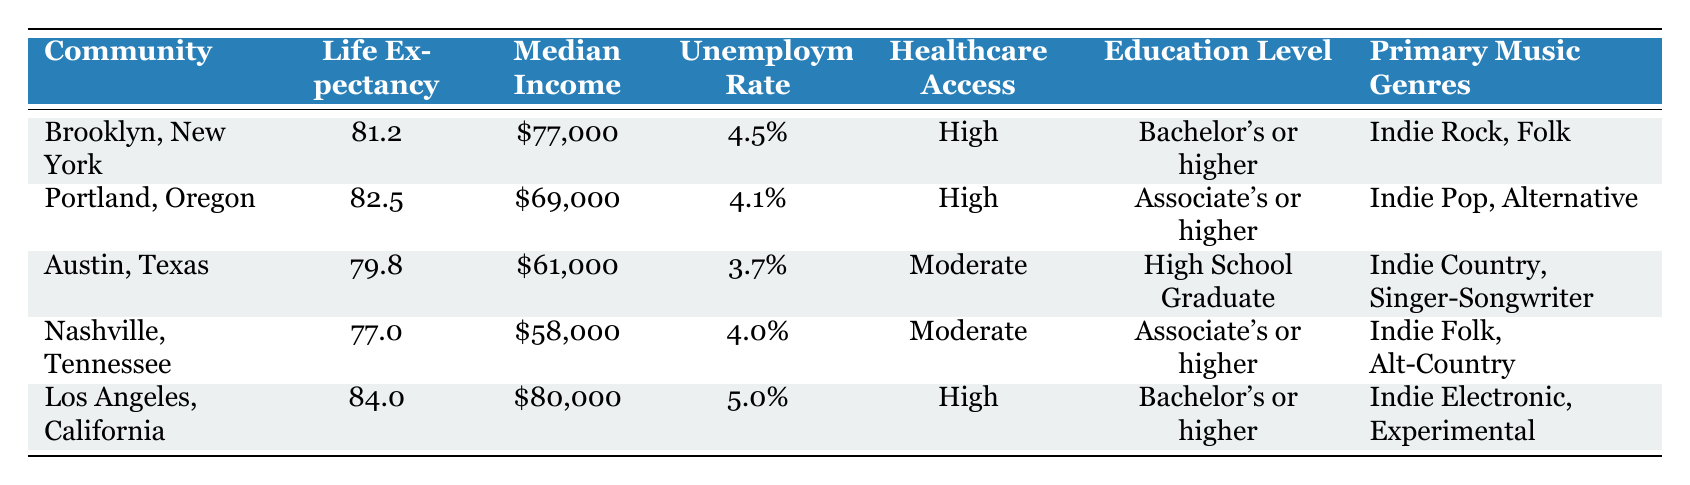What is the average life expectancy across all communities in the table? To find the average life expectancy, add up the average life expectancy values for each community: 81.2 + 82.5 + 79.8 + 77.0 + 84.0 = 404.5. Then, divide by the number of communities (5): 404.5 / 5 = 80.9.
Answer: 80.9 In which community is the median income the highest? By comparing the median income values: Brooklyn has $77,000, Portland $69,000, Austin $61,000, Nashville $58,000, and Los Angeles $80,000. Los Angeles has the highest median income of $80,000.
Answer: Los Angeles, California Which community has a high unemployment rate and moderate access to healthcare? The unemployment rate is high for Los Angeles at 5.0% (but has high healthcare access) and moderate for Austin (3.7%) and Nashville (4.0%). However, Nashville has a moderate unemployment rate (4.0%) and moderate access to healthcare.
Answer: Nashville, Tennessee Is there a community where the median income exceeds the average life expectancy? Comparing median income to average life expectancy: Brooklyn ($77,000 > 81.2), Portland ($69,000 > 82.5), Austin ($61,000 < 79.8), Nashville ($58,000 < 77.0), and Los Angeles ($80,000 > 84.0). Only Brooklyn, Los Angeles, and Portland do not exceed the average life expectancy.
Answer: Yes What is the difference in life expectancy between Austin, Texas, and Portland, Oregon? The life expectancy in Austin is 79.8 and in Portland is 82.5. To find the difference, subtract Austin's life expectancy from Portland's: 82.5 - 79.8 = 2.7.
Answer: 2.7 Which community has the lowest average life expectancy, and what is the primary music genre there? Looking at the average life expectancy, Nashville has the lowest at 77.0. Its primary music genres are Indie Folk and Alt-Country.
Answer: Nashville, Tennessee Does every community listed have at least an associate's degree as the education level? Checking the education levels: Brooklyn has bachelor's or higher, Portland has associate's or higher, Austin has high school graduate, Nashville has associate's or higher, and Los Angeles has bachelor's or higher. Austin does not meet the criteria.
Answer: No How many communities with high access to healthcare have an average life expectancy above 80 years? The communities with high access to healthcare are Brooklyn, Portland, and Los Angeles. Their life expectancies are 81.2, 82.5, and 84.0 respectively. All three exceed 80 years.
Answer: 3 